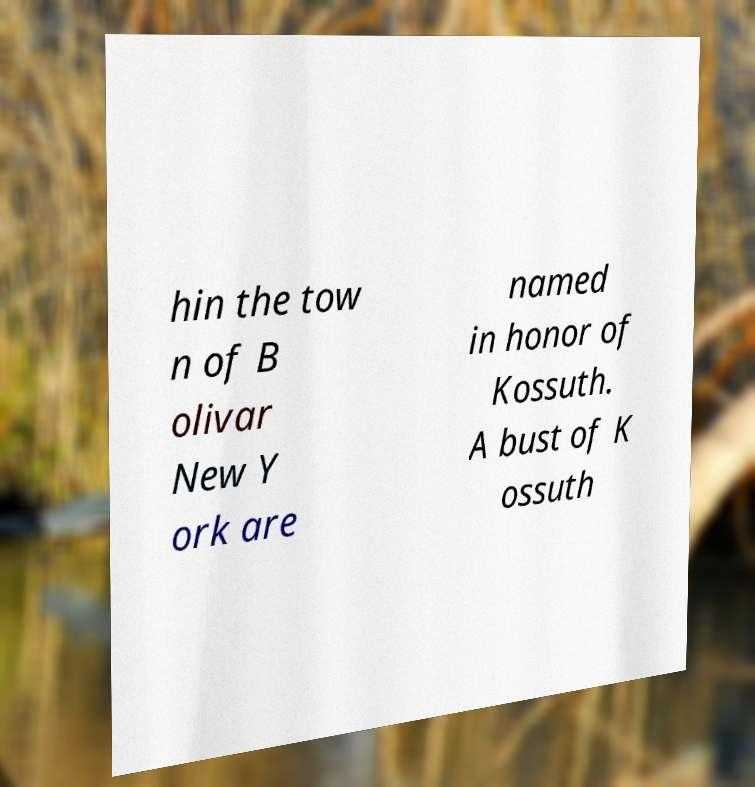Please identify and transcribe the text found in this image. hin the tow n of B olivar New Y ork are named in honor of Kossuth. A bust of K ossuth 